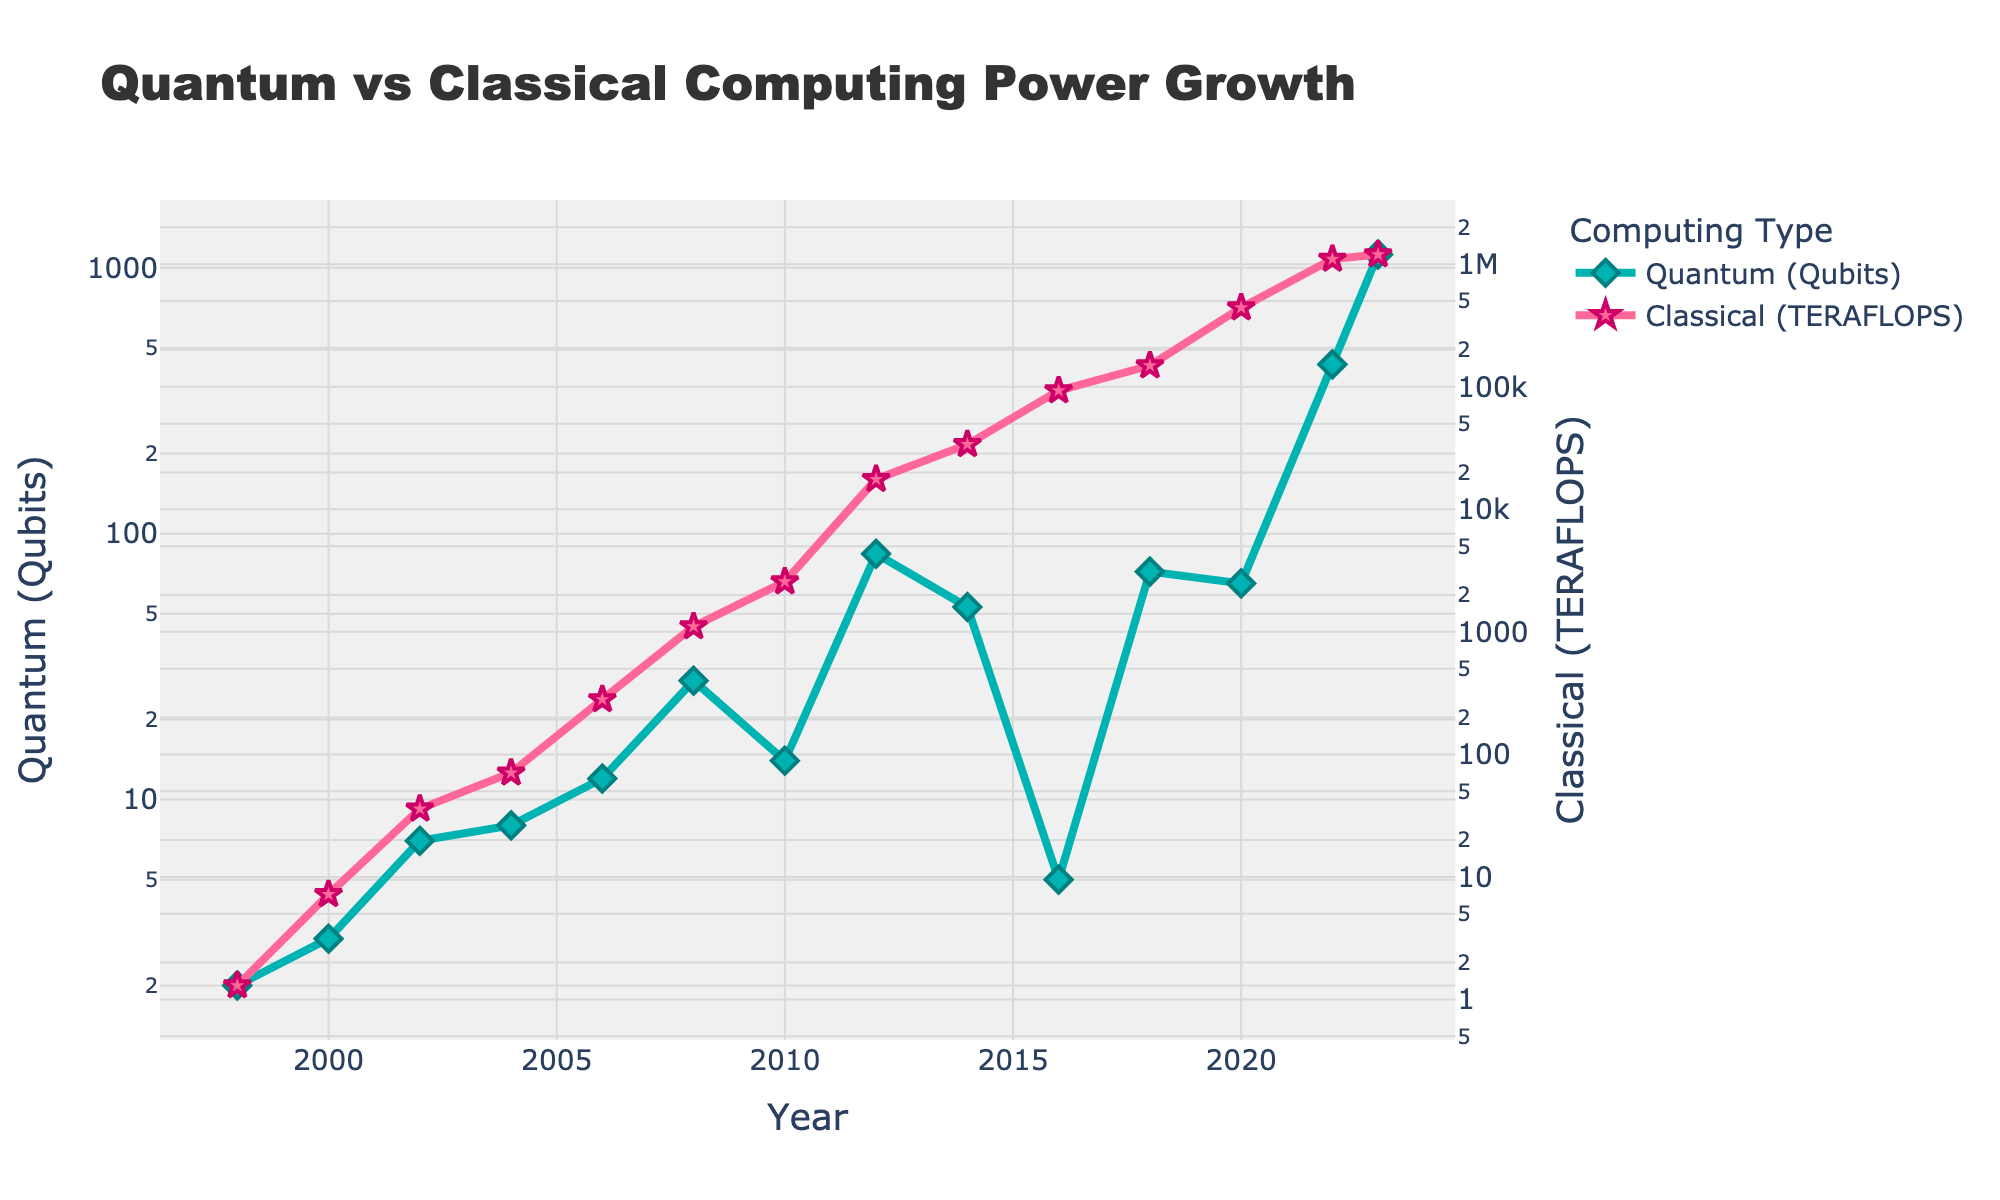What was the quantum computing power in qubits in the year 2023? Look at the 'Quantum (Qubits)' value for the year 2023 on the figure.
Answer: 1121 How much did the classical computing power increase in TERAFLOPS from 2000 to 2008? In 2000, the classical computing power was 7.2 TERAFLOPS, and in 2008, it was 1105.0 TERAFLOPS. The increase = 1105.0 - 7.2 = 1097.8 TERAFLOPS.
Answer: 1097.8 Which year saw the largest leap in quantum computing power measured by the difference in qubits from one year to the next? Compare all the differences between consecutive years for 'Quantum (Qubits)' values: largest leap is from 2022 (433) to 2023 (1121). The difference is 1121 - 433 = 688 qubits.
Answer: 2023 In which year did classical computing power (in TERAFLOPS) first exceed 1000? Locate first year where 'Classical (TERAFLOPS)' crosses 1000 in the figure. This happens in 2008 (1105.0).
Answer: 2008 What is the average quantum computing power (in qubits) from the years 2018 to 2023? To find the average for the years 2018, 2020, 2022, and 2023, sum the quantum (qubits) values for these years and then divide by 4: (72+65+433+1121) / 4 = 1691 / 4 = 422.75
Answer: 422.75 Compare the computing power growth rate: Did classical or quantum computing experience greater exponential growth from 1998 to 2023? Observe the trajectories on the log scale; the slope for quantum (qubits) shows steeper and more rapid growth than classical (TERAFLOPS), indicating greater exponential growth.
Answer: Quantum By what factor did the classical computing power increase from 2012 to 2020? Classical computing power in 2012 was 17590.0 TERAFLOPS, and in 2020 it was 442000.0 TERAFLOPS. The factor increase = 442000.0 / 17590.0 ≈ 25.12
Answer: ~25.12 How many times greater was the quantum computing power in 2023 compared to 1998? Quantum computing power in 2023 is 1121 qubits, and in 1998 it was 2 qubits. The ratio = 1121 / 2 = 560.5
Answer: 560.5 